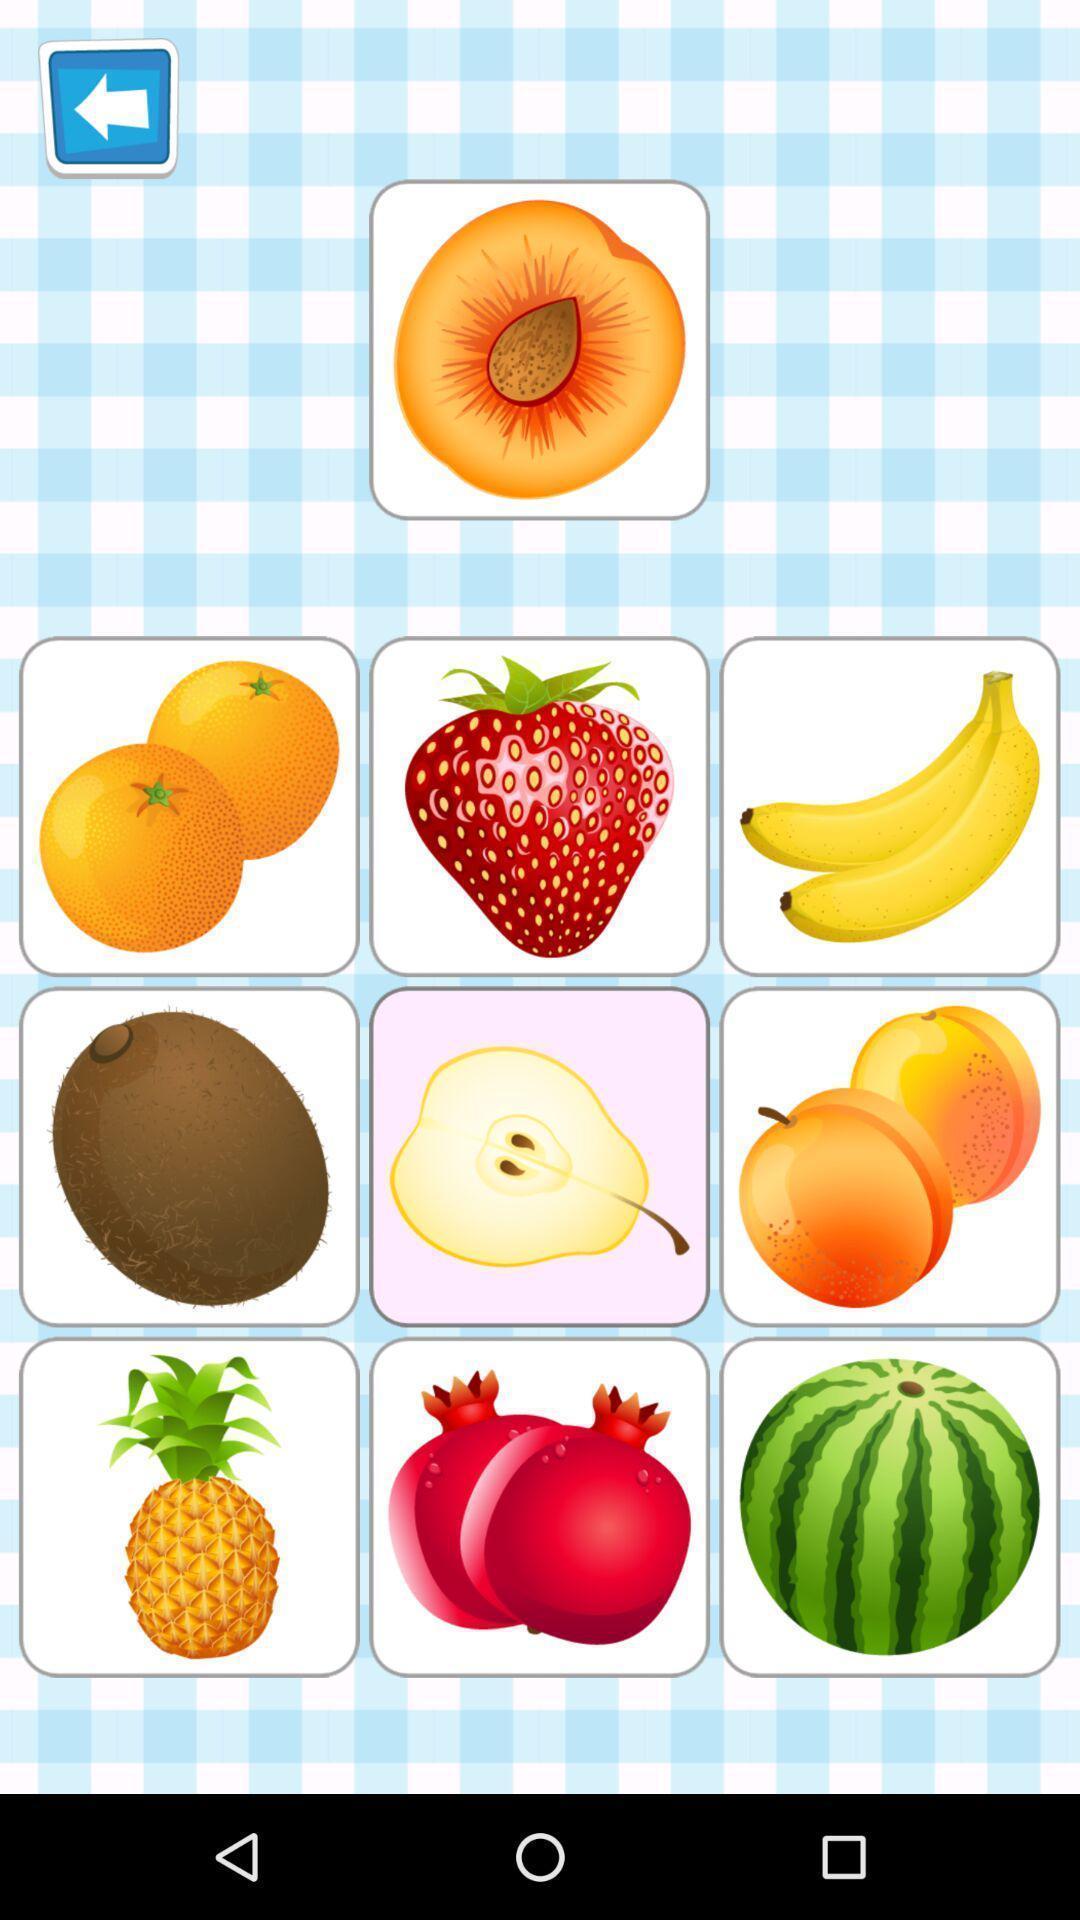Provide a detailed account of this screenshot. Screen showing different fruits images. 